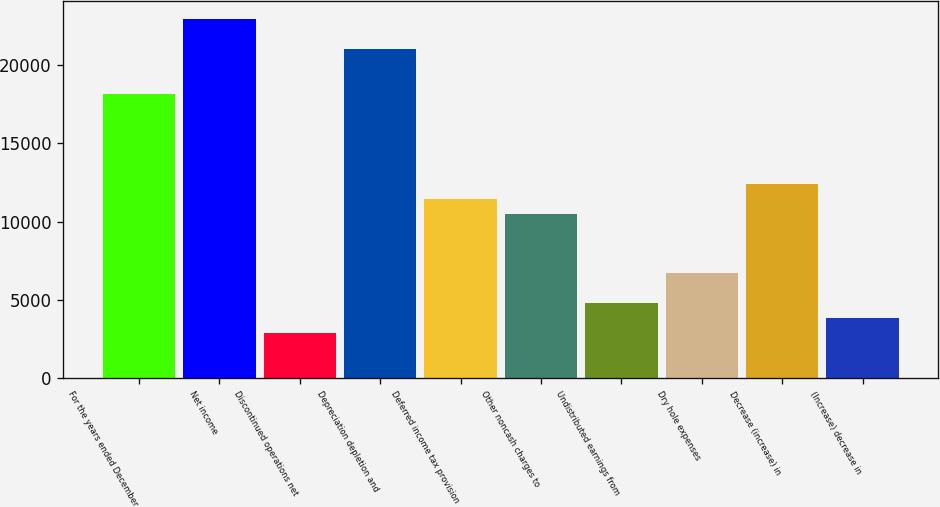Convert chart. <chart><loc_0><loc_0><loc_500><loc_500><bar_chart><fcel>For the years ended December<fcel>Net income<fcel>Discontinued operations net<fcel>Depreciation depletion and<fcel>Deferred income tax provision<fcel>Other noncash charges to<fcel>Undistributed earnings from<fcel>Dry hole expenses<fcel>Decrease (increase) in<fcel>(Increase) decrease in<nl><fcel>18166.4<fcel>22944.4<fcel>2876.8<fcel>21033.2<fcel>11477.2<fcel>10521.6<fcel>4788<fcel>6699.2<fcel>12432.8<fcel>3832.4<nl></chart> 